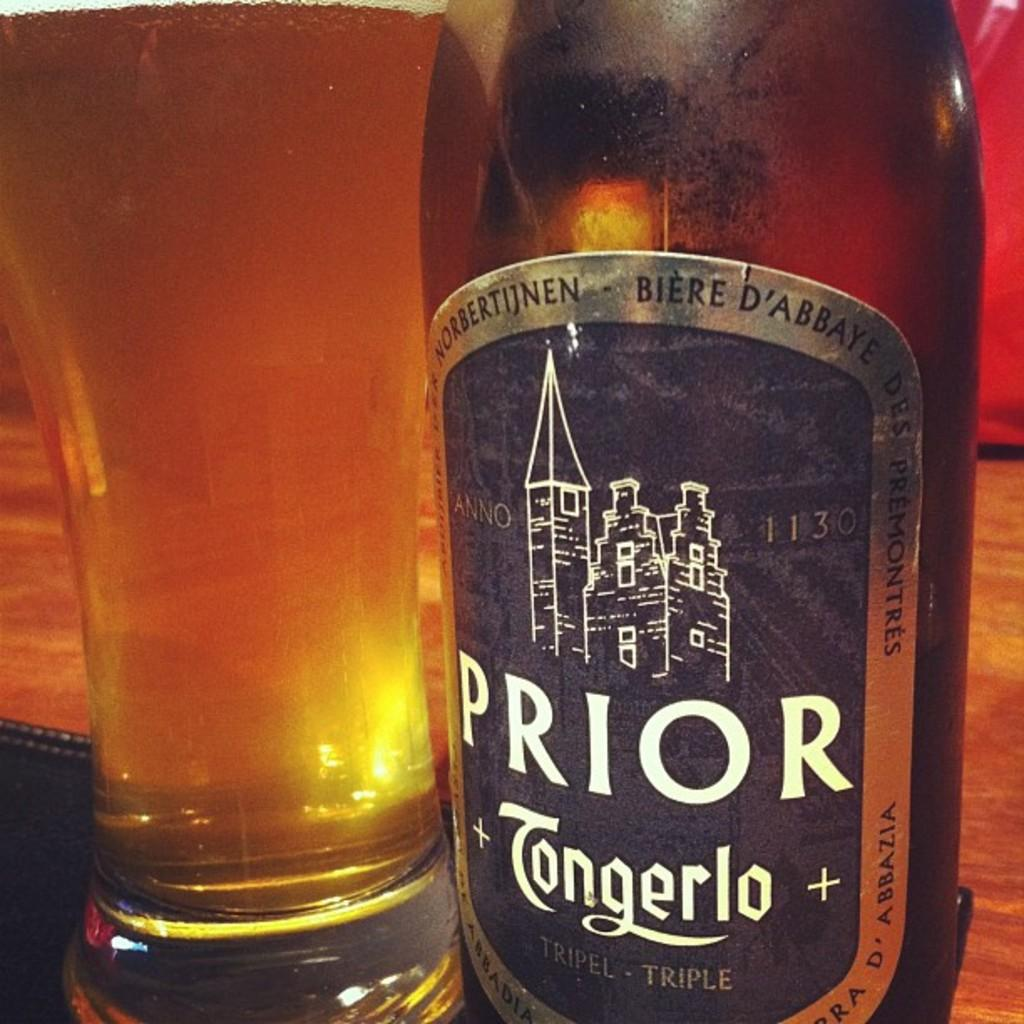<image>
Summarize the visual content of the image. a glass and bottle of Prior Tongerlo Triple drink 